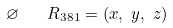<formula> <loc_0><loc_0><loc_500><loc_500>\varnothing \quad R _ { 3 8 1 } & = ( x , \ y , \ z )</formula> 